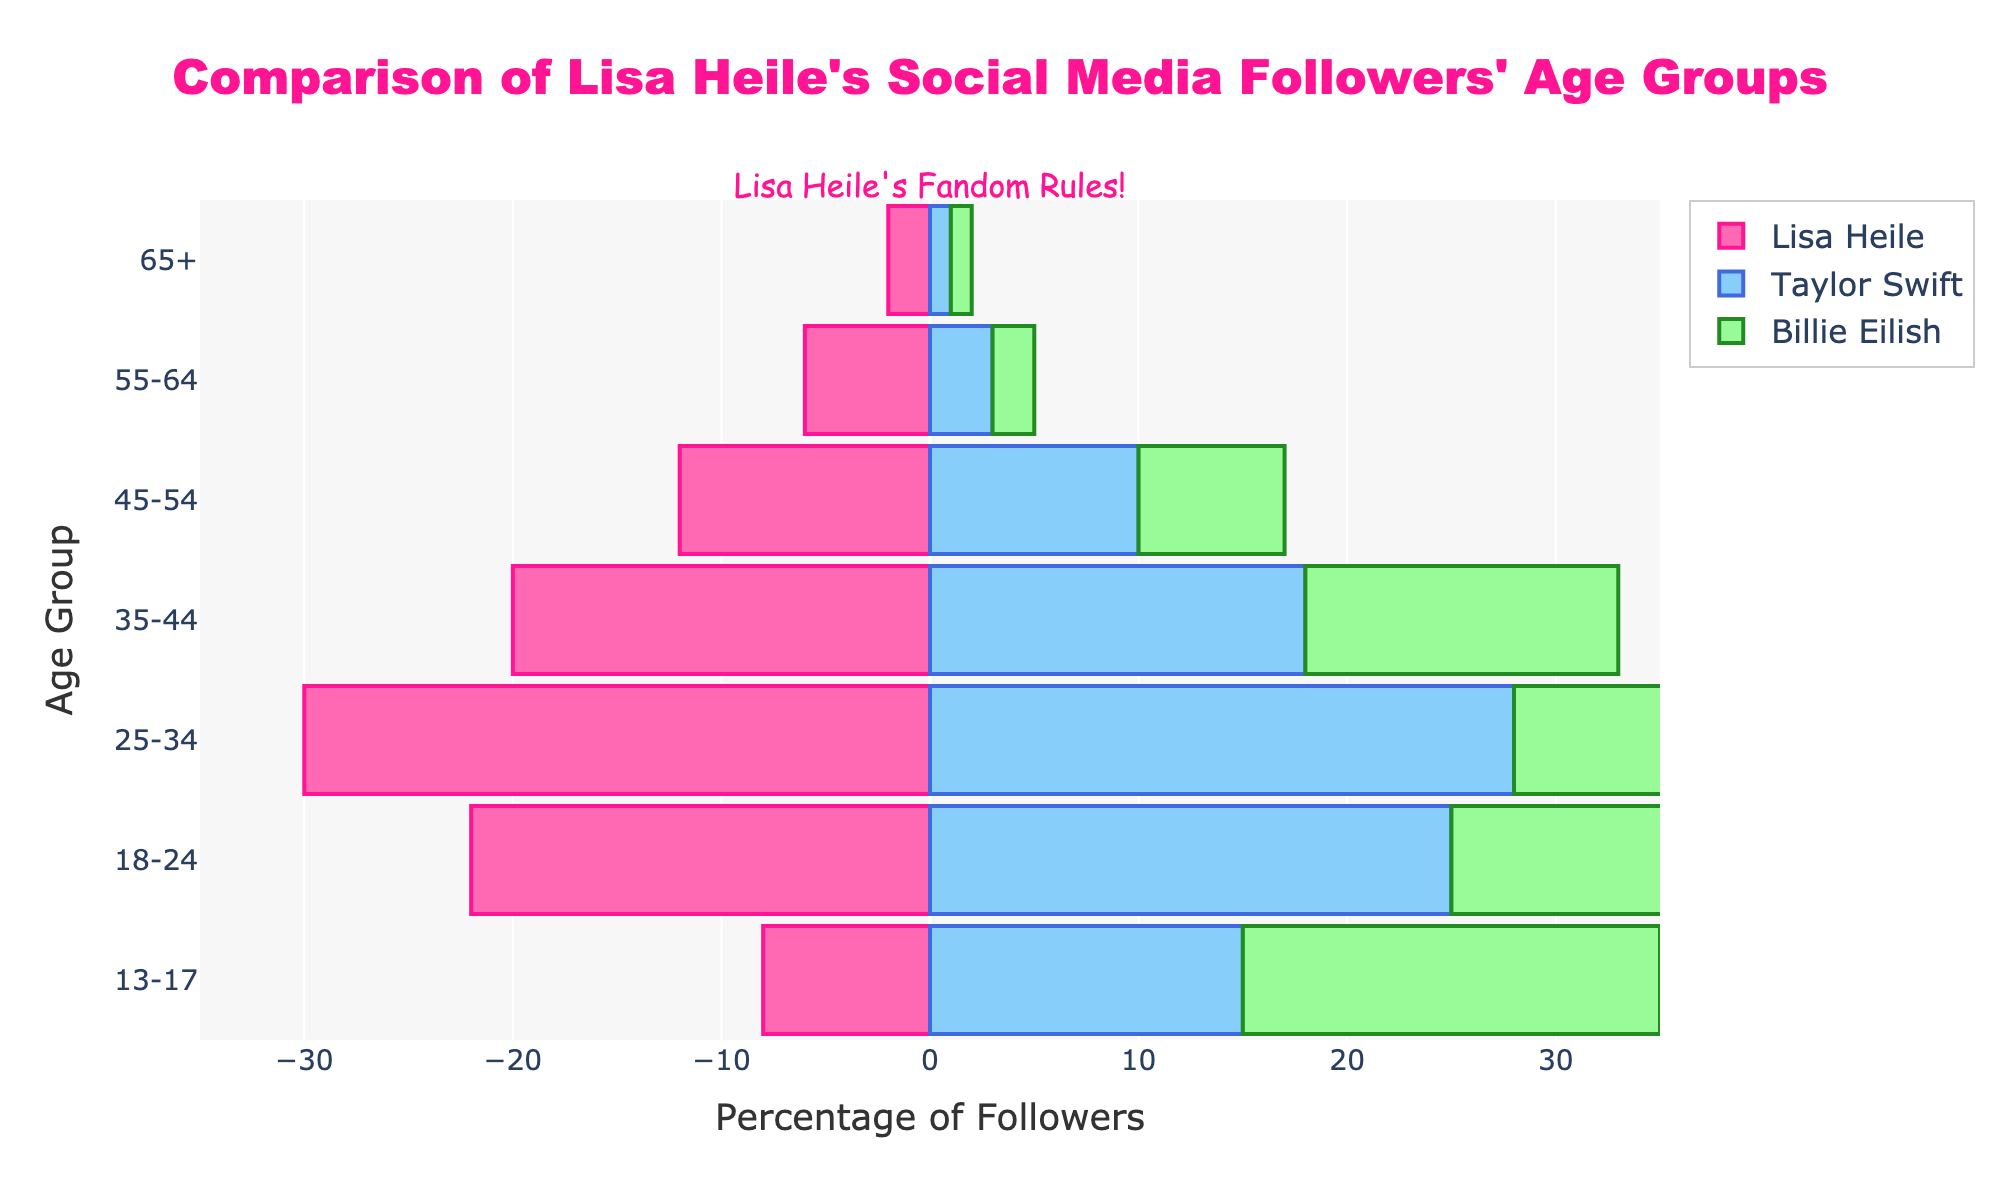What is the title of the figure? The title is displayed at the top center of the figure. It reads "Comparison of Lisa Heile's Social Media Followers' Age Groups."
Answer: Comparison of Lisa Heile's Social Media Followers' Age Groups Which age group has the highest percentage of followers for Lisa Heile? To find this, look at the horizontal bars corresponding to Lisa Heile. The age group with the longest bar represents the highest percentage. This is the "25-34" age group.
Answer: 25-34 Compare the age group 13-17 for all three artists. Who has the highest percentage and who has the lowest? By examining the horizontal bars for the 13-17 age group against Lisa Heile, Taylor Swift, and Billie Eilish, Billie Eilish has the highest percentage (20%), and Lisa Heile has the lowest (8%).
Answer: Billie Eilish, Lisa Heile Which artist has the smallest percentage of followers in the 55-64 age group? Check the bars corresponding to the 55-64 age group for all three artists. Billie Eilish has the smallest with only 2%.
Answer: Billie Eilish Calculate the average percentage of followers in the "35-44" age group across all three artists. Sum up the percentages for the 35-44 age group for each artist (20 + 18 + 15 = 53). Divide by 3 to get the average: 53/3 ≈ 17.67.
Answer: 17.67 Is Lisa Heile more popular among the 18-24 age group compared to 35-44? Compare the lengths of the bars for Lisa Heile in the 18-24 age group (22%) and the 35-44 age group (20%). Lisa Heile is more popular among the 18-24 age group by 2%.
Answer: Yes Which age group has an equal percentage of followers for Taylor Swift and Billie Eilish? Look for age groups where the bars for Taylor Swift and Billie Eilish are of the same length. For the 65+ age group, both have a percentage of 1%.
Answer: 65+ Do all artists have followers in the 65+ age group? Check if there are bars for all three artists in the 65+ age group. Yes, all artists have followers in this group.
Answer: Yes Calculate the difference in percentage between Lisa Heile’s and Taylor Swift's followers in the 45-54 age group. Subtract Taylor Swift's percentage (10%) from Lisa Heile’s percentage (12%) for the 45-54 age group. The difference is 12 - 10 = 2%.
Answer: 2 Which artist has the smallest difference between their highest and lowest age group percentages? Calculate the difference between highest and lowest percentages for each artist: Lisa Heile (30-2=28), Taylor Swift (28-1=27), Billie Eilish (30-1=29). Taylor Swift has the smallest difference with 27%.
Answer: Taylor Swift 